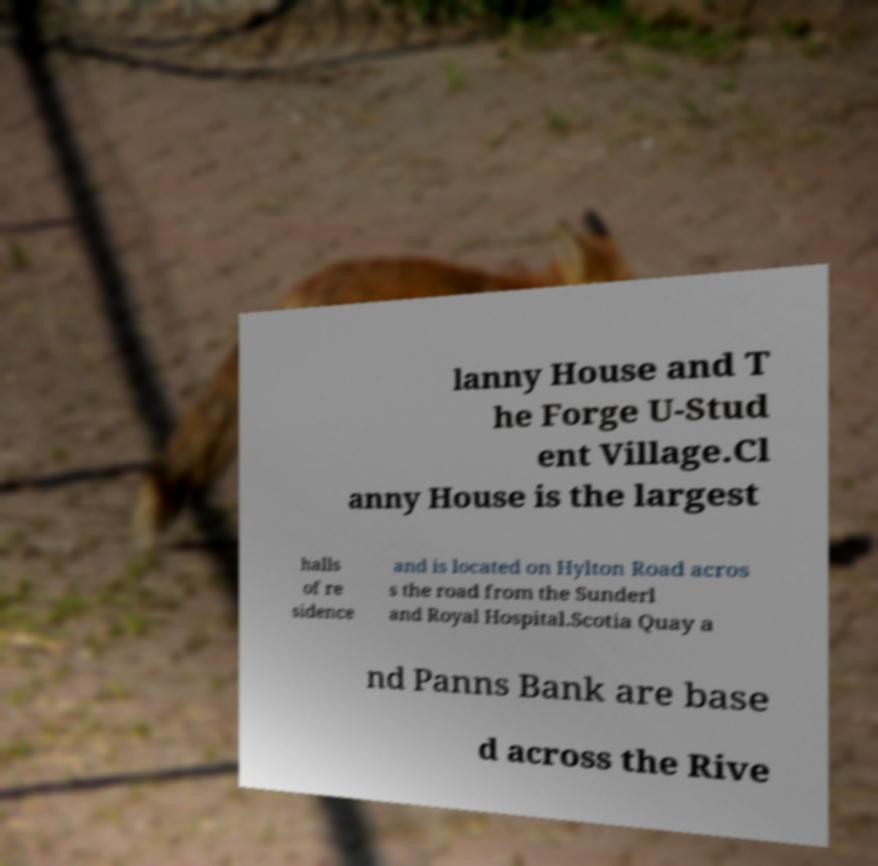Could you assist in decoding the text presented in this image and type it out clearly? lanny House and T he Forge U-Stud ent Village.Cl anny House is the largest halls of re sidence and is located on Hylton Road acros s the road from the Sunderl and Royal Hospital.Scotia Quay a nd Panns Bank are base d across the Rive 